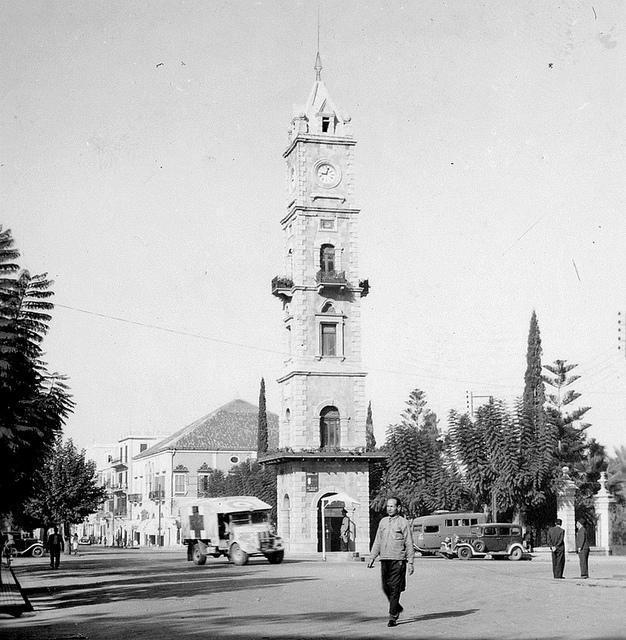How many trucks are there?
Give a very brief answer. 2. How many people are wearing a orange shirt?
Give a very brief answer. 0. 